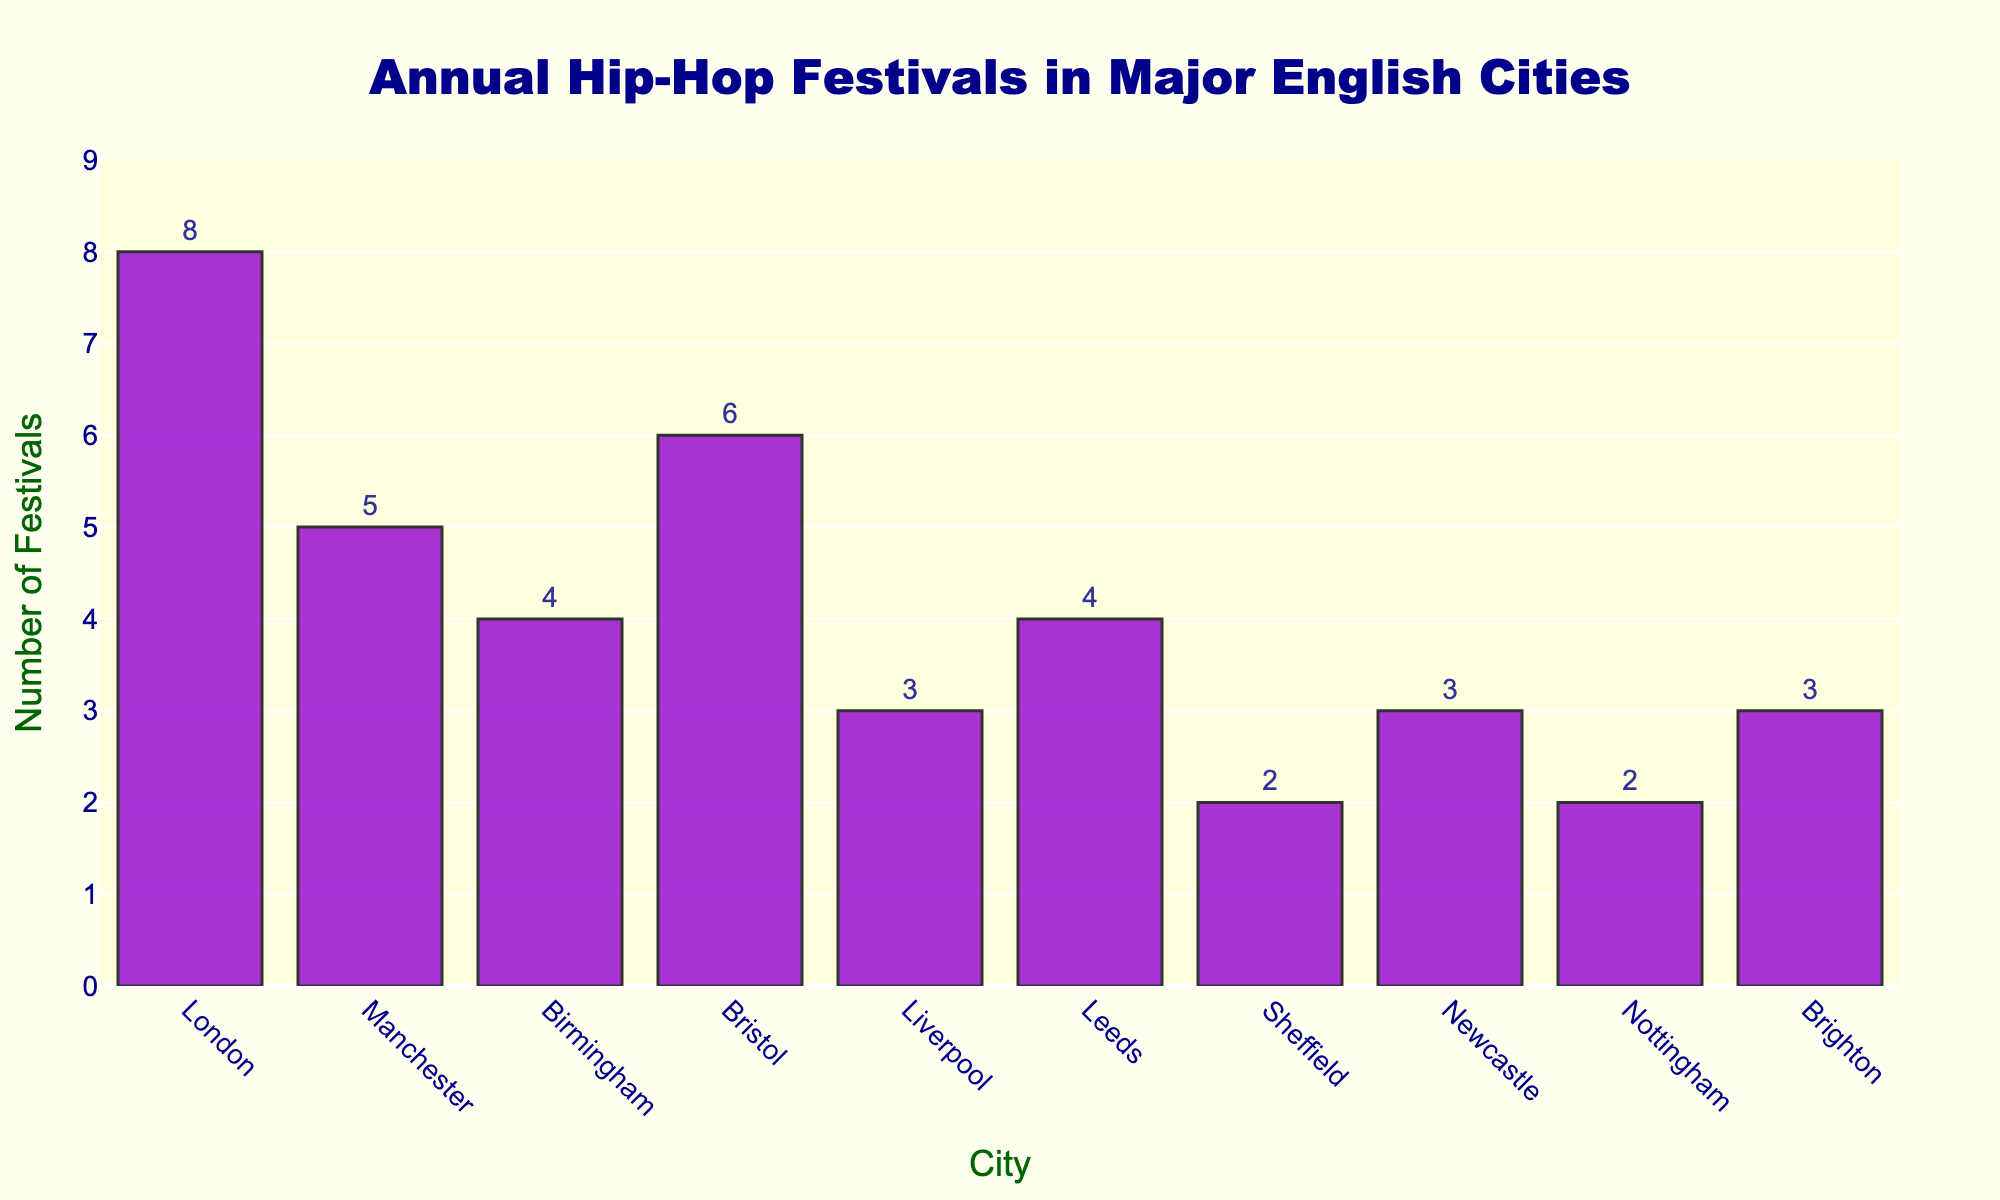Which city hosts the most annual hip-hop festivals? Observe the height of all the bars and identify the tallest one. The tallest bar represents London, indicating it hosts the most festivals.
Answer: London What is the total number of annual hip-hop festivals hosted by Leeds and Sheffield combined? Add the number of festivals for Leeds (4) and Sheffield (2). The sum is 4 + 2 = 6.
Answer: 6 Which cities host fewer than 4 annual hip-hop festivals? Look for bars with a height less than 4 on the y-axis. This includes Liverpool, Sheffield, Newcastle, and Nottingham.
Answer: Liverpool, Sheffield, Newcastle, Nottingham How many more festivals does Bristol have compared to Birmingham? Calculate the difference between the number of festivals in Bristol (6) and Birmingham (4). The difference is 6 - 4 = 2.
Answer: 2 What is the average number of hip-hop festivals hosted annually by London, Manchester, and Birmingham? Sum the number of festivals for London (8), Manchester (5), and Birmingham (4), and divide by the number of cities: (8 + 5 + 4) / 3 = 17 / 3 ≈ 5.67.
Answer: 5.67 Which two cities host the same number of annual hip-hop festivals? Identify bars with equal heights. Leeds and Birmingham both have bars with heights of 4.
Answer: Leeds and Birmingham Are there more cities hosting at least 4 festivals annually or fewer than 4? Count the cities hosting 4 or more festivals (London, Manchester, Bristol, Birmingham, Leeds) and those hosting fewer than 4 (Liverpool, Sheffield, Newcastle, Nottingham, Brighton). Both groups have 5 cities each.
Answer: Equal What is the combined number of hip-hop festivals hosted by Brighton and Liverpool? Add the number of festivals for Brighton (3) and Liverpool (3). The sum is 3 + 3 = 6.
Answer: 6 Is the number of hip-hop festivals in Manchester more than in Sheffield and Nottingham combined? Compare Manchester's festivals (5) with the sum of Sheffield's (2) and Nottingham's (2). The sum is 2 + 2 = 4, and 5 is greater than 4.
Answer: Yes 